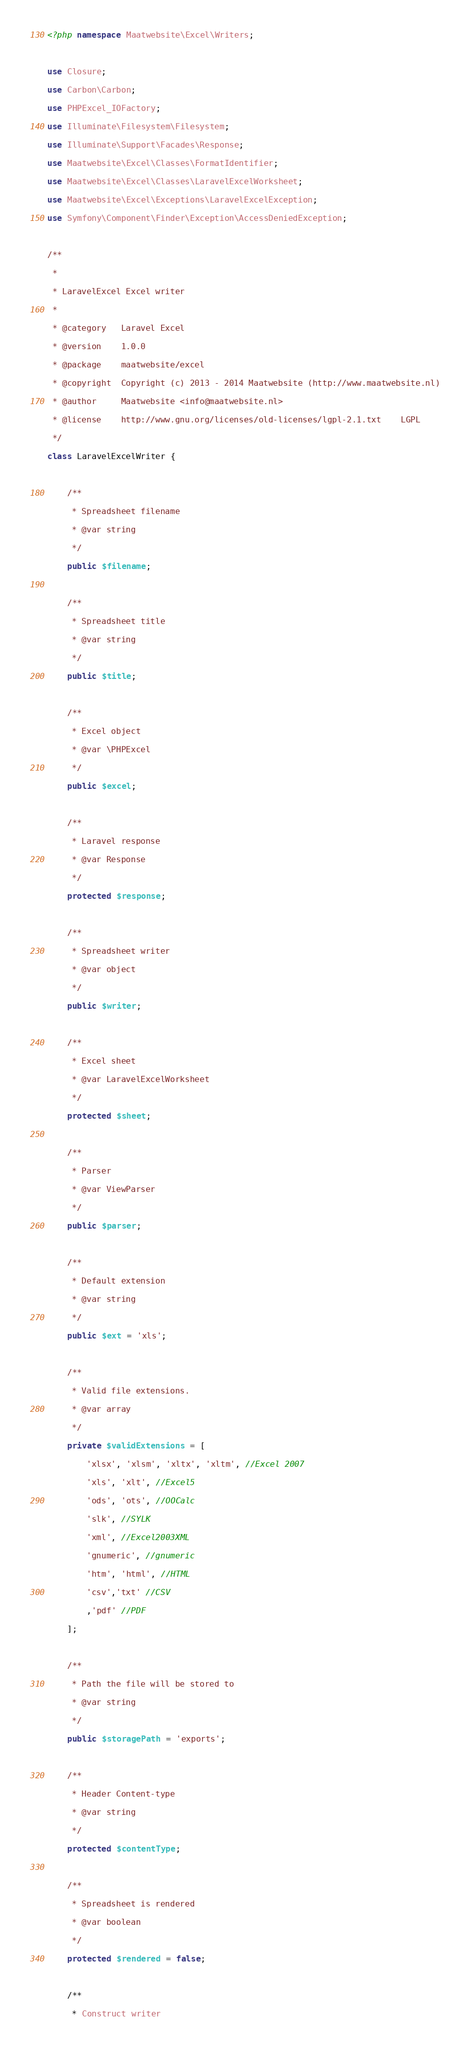Convert code to text. <code><loc_0><loc_0><loc_500><loc_500><_PHP_><?php namespace Maatwebsite\Excel\Writers;

use Closure;
use Carbon\Carbon;
use PHPExcel_IOFactory;
use Illuminate\Filesystem\Filesystem;
use Illuminate\Support\Facades\Response;
use Maatwebsite\Excel\Classes\FormatIdentifier;
use Maatwebsite\Excel\Classes\LaravelExcelWorksheet;
use Maatwebsite\Excel\Exceptions\LaravelExcelException;
use Symfony\Component\Finder\Exception\AccessDeniedException;

/**
 *
 * LaravelExcel Excel writer
 *
 * @category   Laravel Excel
 * @version    1.0.0
 * @package    maatwebsite/excel
 * @copyright  Copyright (c) 2013 - 2014 Maatwebsite (http://www.maatwebsite.nl)
 * @author     Maatwebsite <info@maatwebsite.nl>
 * @license    http://www.gnu.org/licenses/old-licenses/lgpl-2.1.txt    LGPL
 */
class LaravelExcelWriter {

    /**
     * Spreadsheet filename
     * @var string
     */
    public $filename;

    /**
     * Spreadsheet title
     * @var string
     */
    public $title;

    /**
     * Excel object
     * @var \PHPExcel
     */
    public $excel;

    /**
     * Laravel response
     * @var Response
     */
    protected $response;

    /**
     * Spreadsheet writer
     * @var object
     */
    public $writer;

    /**
     * Excel sheet
     * @var LaravelExcelWorksheet
     */
    protected $sheet;

    /**
     * Parser
     * @var ViewParser
     */
    public $parser;

    /**
     * Default extension
     * @var string
     */
    public $ext = 'xls';

    /**
     * Valid file extensions.
     * @var array
     */
    private $validExtensions = [
        'xlsx', 'xlsm', 'xltx', 'xltm', //Excel 2007
        'xls', 'xlt', //Excel5
        'ods', 'ots', //OOCalc
        'slk', //SYLK
        'xml', //Excel2003XML
        'gnumeric', //gnumeric
        'htm', 'html', //HTML
        'csv','txt' //CSV
        ,'pdf' //PDF
    ];

    /**
     * Path the file will be stored to
     * @var string
     */
    public $storagePath = 'exports';

    /**
     * Header Content-type
     * @var string
     */
    protected $contentType;

    /**
     * Spreadsheet is rendered
     * @var boolean
     */
    protected $rendered = false;

    /**
     * Construct writer</code> 